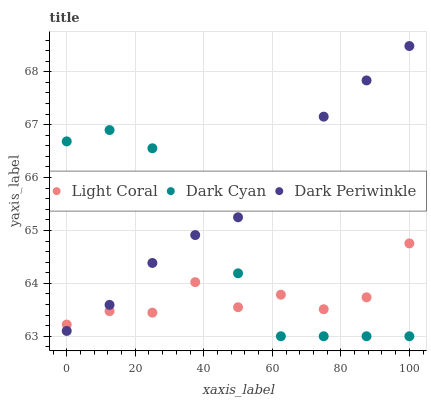Does Light Coral have the minimum area under the curve?
Answer yes or no. Yes. Does Dark Periwinkle have the maximum area under the curve?
Answer yes or no. Yes. Does Dark Cyan have the minimum area under the curve?
Answer yes or no. No. Does Dark Cyan have the maximum area under the curve?
Answer yes or no. No. Is Dark Cyan the smoothest?
Answer yes or no. Yes. Is Light Coral the roughest?
Answer yes or no. Yes. Is Dark Periwinkle the smoothest?
Answer yes or no. No. Is Dark Periwinkle the roughest?
Answer yes or no. No. Does Dark Cyan have the lowest value?
Answer yes or no. Yes. Does Dark Periwinkle have the lowest value?
Answer yes or no. No. Does Dark Periwinkle have the highest value?
Answer yes or no. Yes. Does Dark Cyan have the highest value?
Answer yes or no. No. Does Light Coral intersect Dark Cyan?
Answer yes or no. Yes. Is Light Coral less than Dark Cyan?
Answer yes or no. No. Is Light Coral greater than Dark Cyan?
Answer yes or no. No. 